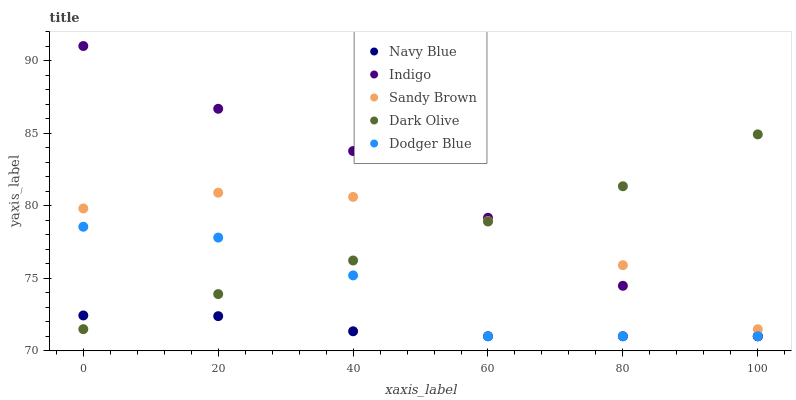Does Navy Blue have the minimum area under the curve?
Answer yes or no. Yes. Does Indigo have the maximum area under the curve?
Answer yes or no. Yes. Does Dark Olive have the minimum area under the curve?
Answer yes or no. No. Does Dark Olive have the maximum area under the curve?
Answer yes or no. No. Is Dark Olive the smoothest?
Answer yes or no. Yes. Is Dodger Blue the roughest?
Answer yes or no. Yes. Is Indigo the smoothest?
Answer yes or no. No. Is Indigo the roughest?
Answer yes or no. No. Does Navy Blue have the lowest value?
Answer yes or no. Yes. Does Dark Olive have the lowest value?
Answer yes or no. No. Does Indigo have the highest value?
Answer yes or no. Yes. Does Dark Olive have the highest value?
Answer yes or no. No. Is Navy Blue less than Sandy Brown?
Answer yes or no. Yes. Is Sandy Brown greater than Navy Blue?
Answer yes or no. Yes. Does Indigo intersect Navy Blue?
Answer yes or no. Yes. Is Indigo less than Navy Blue?
Answer yes or no. No. Is Indigo greater than Navy Blue?
Answer yes or no. No. Does Navy Blue intersect Sandy Brown?
Answer yes or no. No. 